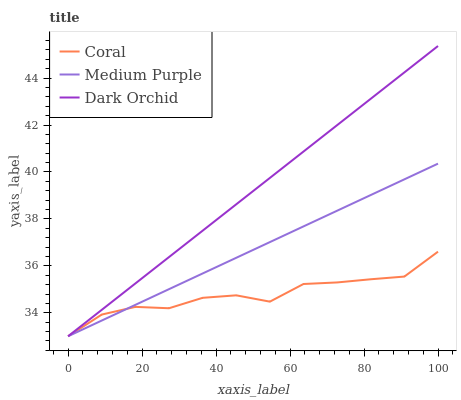Does Coral have the minimum area under the curve?
Answer yes or no. Yes. Does Dark Orchid have the maximum area under the curve?
Answer yes or no. Yes. Does Dark Orchid have the minimum area under the curve?
Answer yes or no. No. Does Coral have the maximum area under the curve?
Answer yes or no. No. Is Dark Orchid the smoothest?
Answer yes or no. Yes. Is Coral the roughest?
Answer yes or no. Yes. Is Coral the smoothest?
Answer yes or no. No. Is Dark Orchid the roughest?
Answer yes or no. No. Does Medium Purple have the lowest value?
Answer yes or no. Yes. Does Dark Orchid have the highest value?
Answer yes or no. Yes. Does Coral have the highest value?
Answer yes or no. No. Does Medium Purple intersect Dark Orchid?
Answer yes or no. Yes. Is Medium Purple less than Dark Orchid?
Answer yes or no. No. Is Medium Purple greater than Dark Orchid?
Answer yes or no. No. 